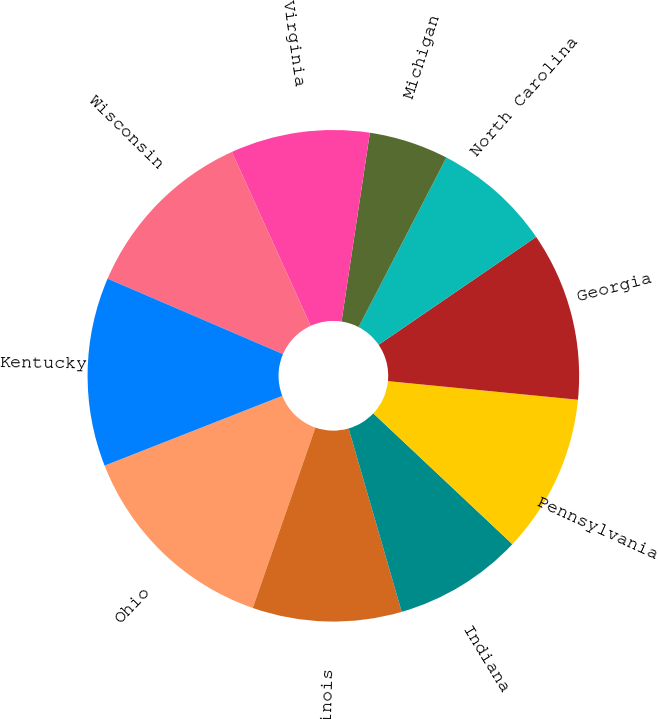Convert chart. <chart><loc_0><loc_0><loc_500><loc_500><pie_chart><fcel>Ohio<fcel>Illinois<fcel>Indiana<fcel>Pennsylvania<fcel>Georgia<fcel>North Carolina<fcel>Michigan<fcel>Virginia<fcel>Wisconsin<fcel>Kentucky<nl><fcel>13.73%<fcel>9.8%<fcel>8.5%<fcel>10.46%<fcel>11.11%<fcel>7.84%<fcel>5.23%<fcel>9.15%<fcel>11.76%<fcel>12.42%<nl></chart> 